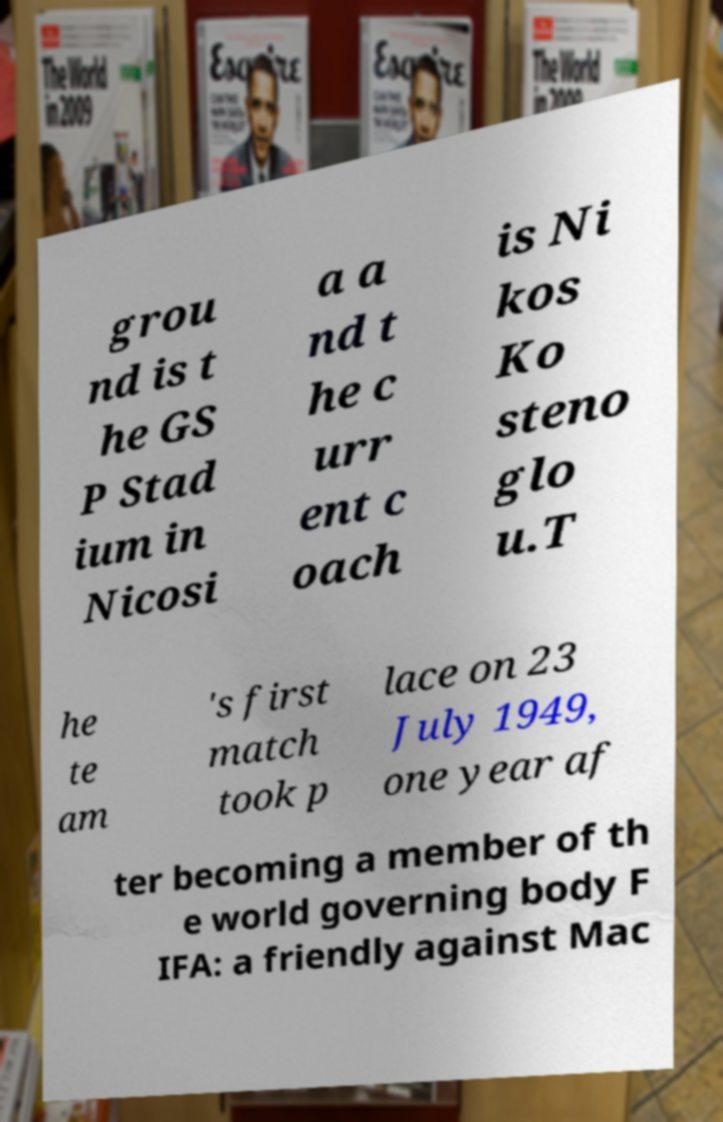Can you read and provide the text displayed in the image?This photo seems to have some interesting text. Can you extract and type it out for me? grou nd is t he GS P Stad ium in Nicosi a a nd t he c urr ent c oach is Ni kos Ko steno glo u.T he te am 's first match took p lace on 23 July 1949, one year af ter becoming a member of th e world governing body F IFA: a friendly against Mac 